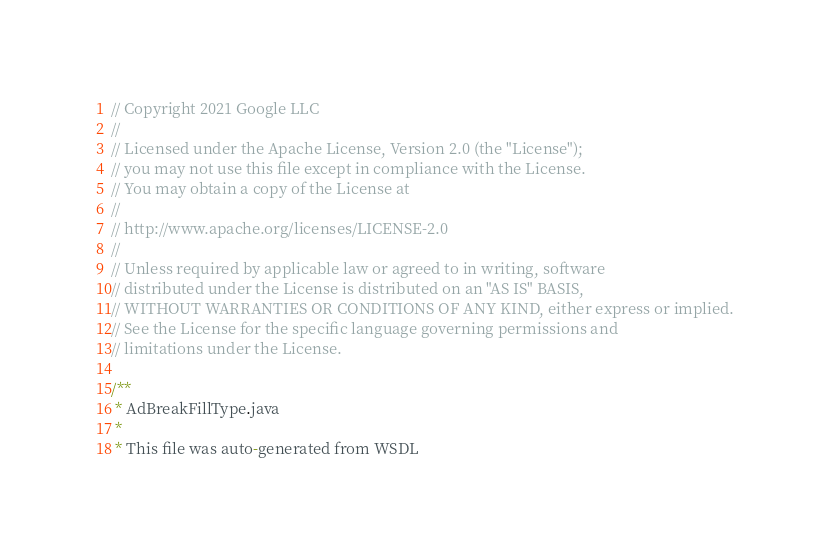<code> <loc_0><loc_0><loc_500><loc_500><_Java_>// Copyright 2021 Google LLC
//
// Licensed under the Apache License, Version 2.0 (the "License");
// you may not use this file except in compliance with the License.
// You may obtain a copy of the License at
//
// http://www.apache.org/licenses/LICENSE-2.0
//
// Unless required by applicable law or agreed to in writing, software
// distributed under the License is distributed on an "AS IS" BASIS,
// WITHOUT WARRANTIES OR CONDITIONS OF ANY KIND, either express or implied.
// See the License for the specific language governing permissions and
// limitations under the License.

/**
 * AdBreakFillType.java
 *
 * This file was auto-generated from WSDL</code> 